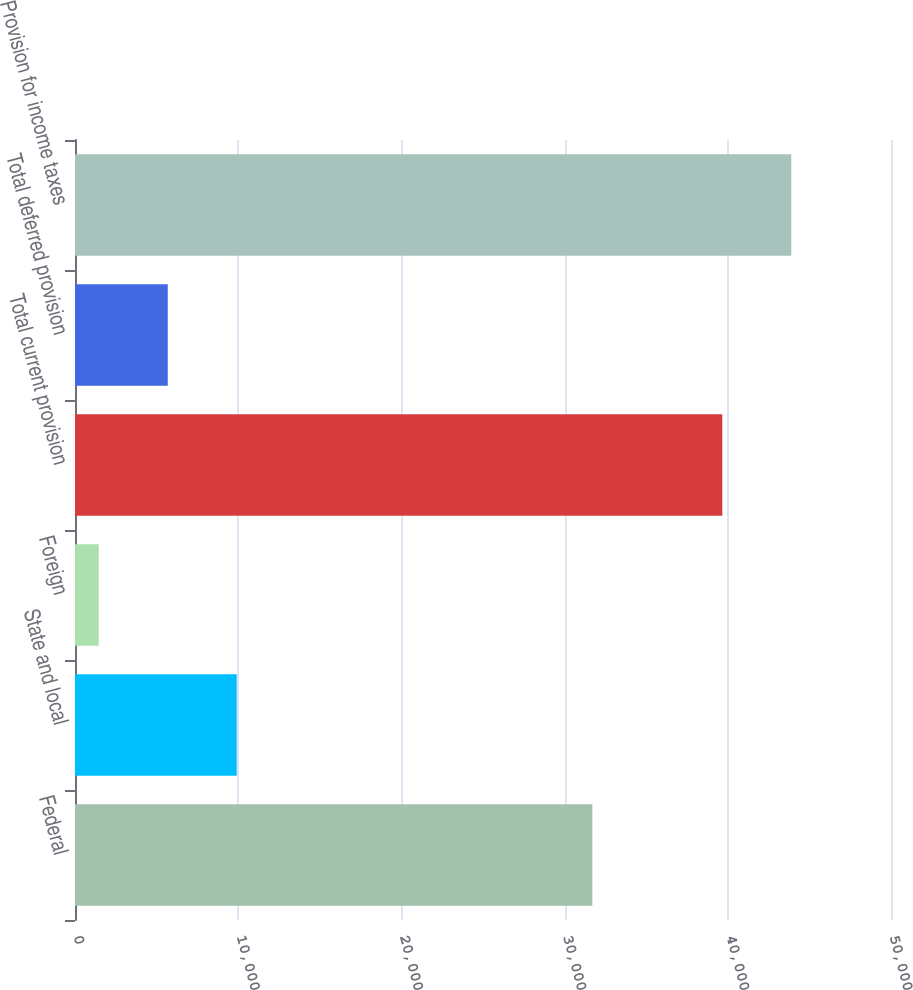Convert chart to OTSL. <chart><loc_0><loc_0><loc_500><loc_500><bar_chart><fcel>Federal<fcel>State and local<fcel>Foreign<fcel>Total current provision<fcel>Total deferred provision<fcel>Provision for income taxes<nl><fcel>31700<fcel>9910.8<fcel>1456<fcel>39661<fcel>5683.4<fcel>43888.4<nl></chart> 